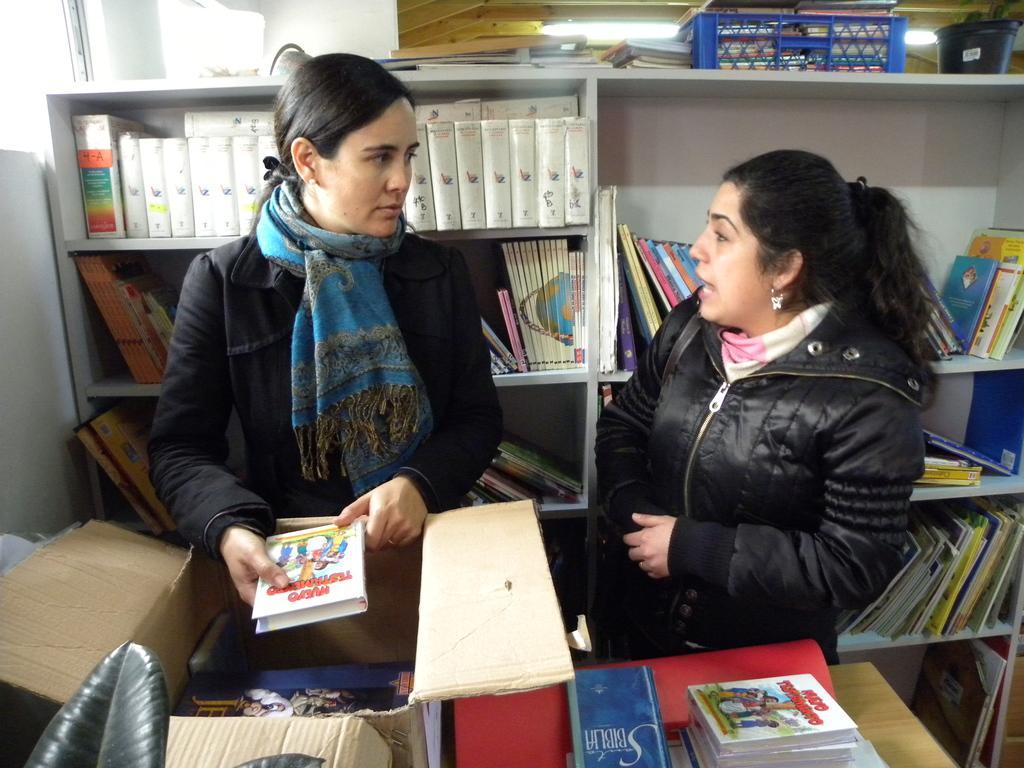Please provide a concise description of this image. In this image I can see number of books in the front and in the background. I can also see two women are standing in the centre and I can see both of them are wearing jackets. I can see the left one is holding a white colour book and under her hands I can see a box and a table. On the bottom left side of this image I can see two leaves and on the top right side of this image I can see a blue colour thing, a pot and few others stuffs. 